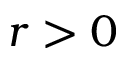Convert formula to latex. <formula><loc_0><loc_0><loc_500><loc_500>r > 0</formula> 